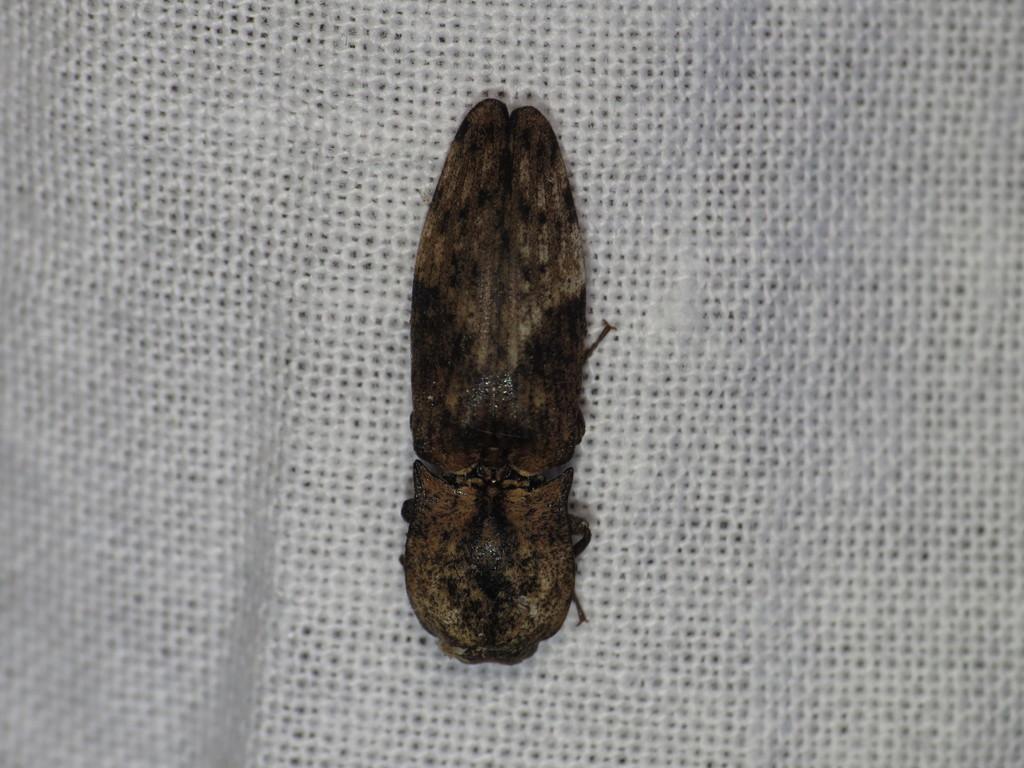Please provide a concise description of this image. In the foreground of this image, there is an insect on a white surface. 